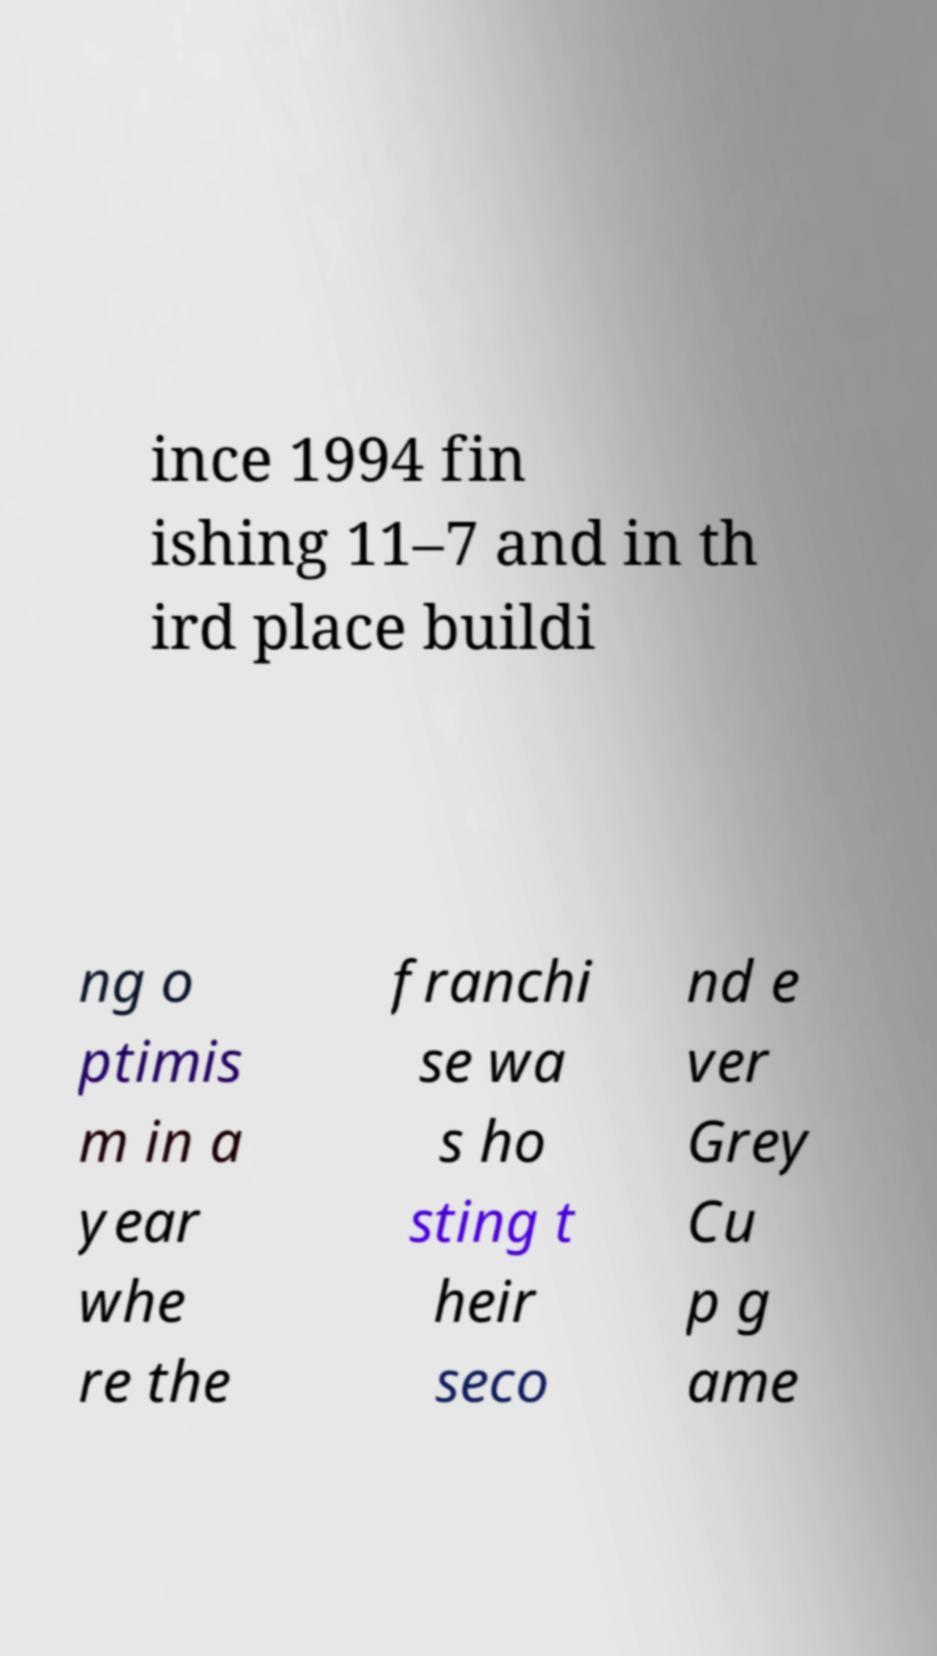Please identify and transcribe the text found in this image. ince 1994 fin ishing 11–7 and in th ird place buildi ng o ptimis m in a year whe re the franchi se wa s ho sting t heir seco nd e ver Grey Cu p g ame 